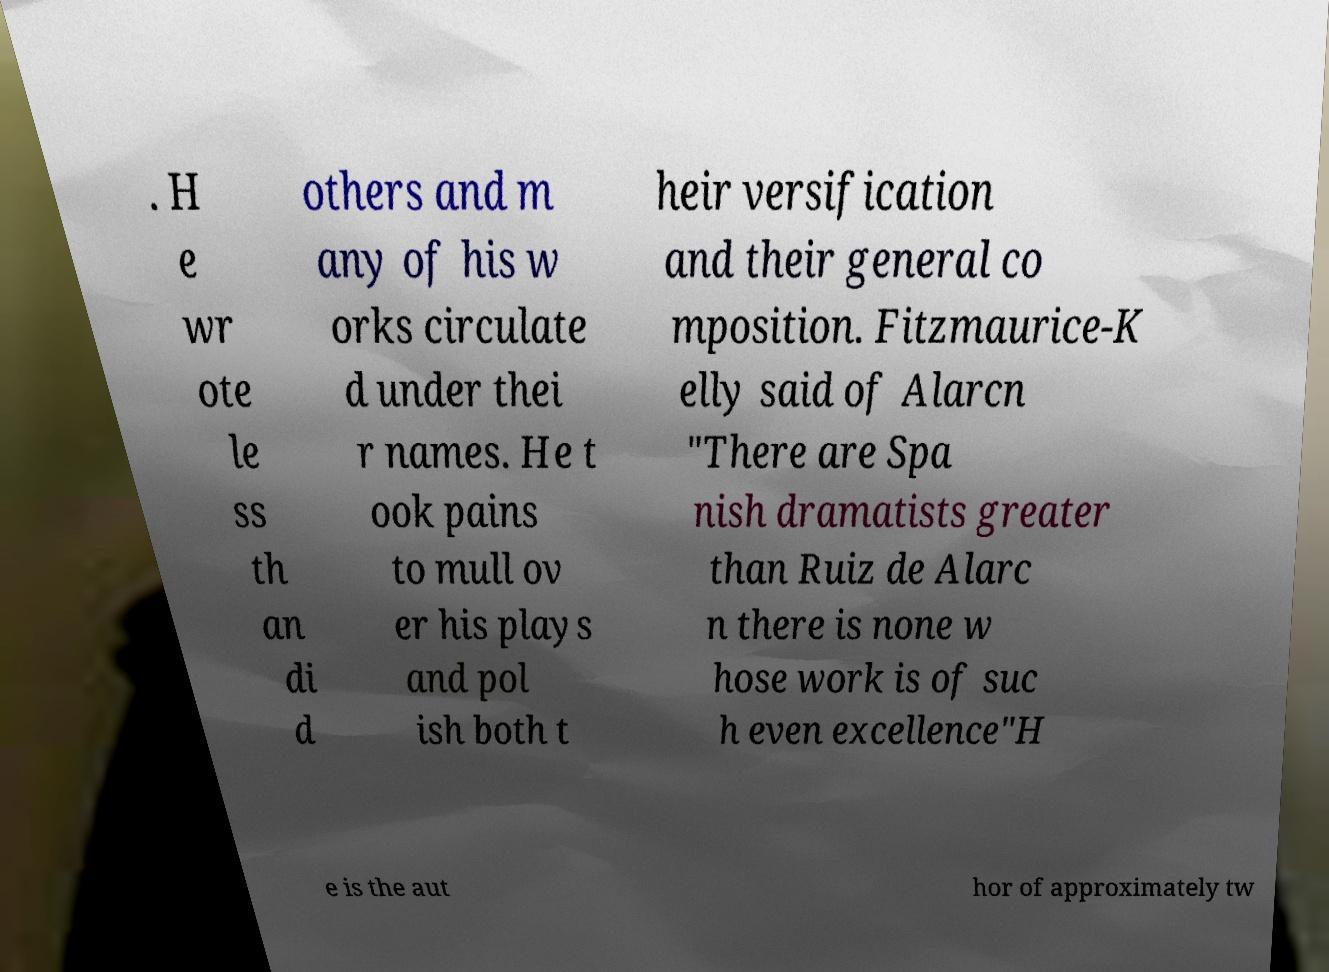I need the written content from this picture converted into text. Can you do that? . H e wr ote le ss th an di d others and m any of his w orks circulate d under thei r names. He t ook pains to mull ov er his plays and pol ish both t heir versification and their general co mposition. Fitzmaurice-K elly said of Alarcn "There are Spa nish dramatists greater than Ruiz de Alarc n there is none w hose work is of suc h even excellence"H e is the aut hor of approximately tw 